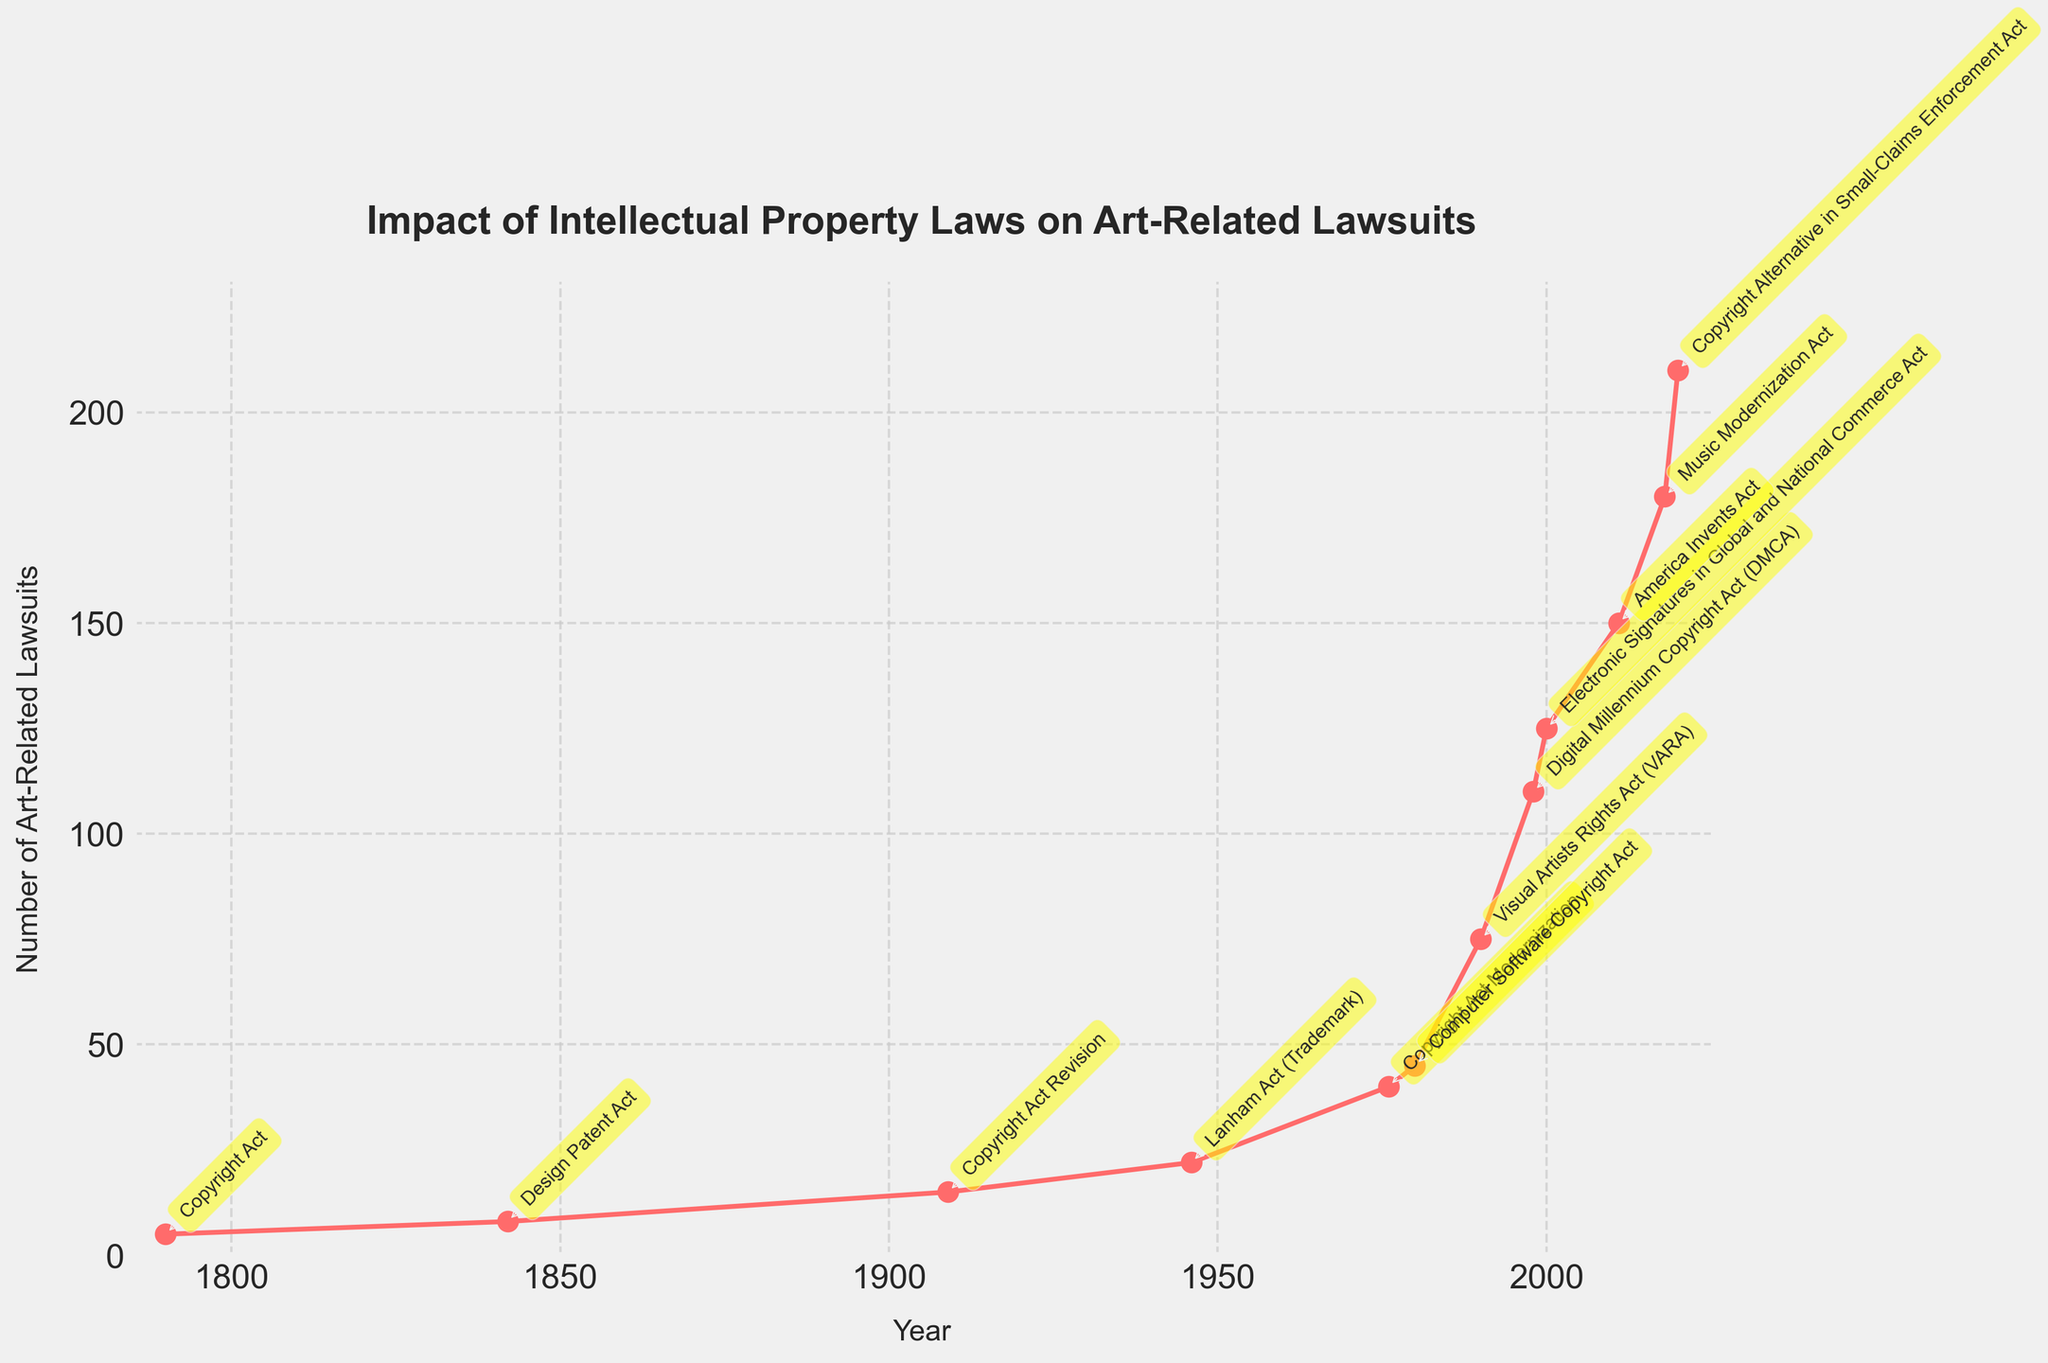what was the impact on art-related lawsuits after the Copyright Act of 1790? The figure shows the number of art-related lawsuits at various years. For 1790, associated with the Copyright Act, the number of lawsuits was indicated.
Answer: 5 How much did the number of art-related lawsuits increase between the Copyright Act of 1790 and the Design Patent Act of 1842? The number of lawsuits in 1790 was 5, and in 1842 it was 8. The increase can be calculated by subtracting the former from the latter: 8 - 5 = 3.
Answer: 3 Which law corresponds to the highest increase in the number of art-related lawsuits compared to its predecessor? By examining the rises in lawsuits at each legal milestone, the largest gap appears between the 1990 VARA (75) and the 1998 DMCA (110), giving an increase of 35, the highest among the intervals.
Answer: Digital Millennium Copyright Act Was there a higher impact on art-related lawsuits following the Lanham Act (1946) or the Copyright Act Modernization (1976)? The impact following the 1946 Lanham Act was 22, whereas the impact following the 1976 Copyright Act Modernization was 40. Hence, 1976 had a higher impact.
Answer: Copyright Act Modernization What is the overall trend in the number of art-related lawsuits from 1790 to 2020? Observing the line plot from 1790 to 2020, the lawsuits show a general upward trend, indicating that the number of art-related lawsuits has increased over time.
Answer: Upward Trend How many years after the Lanham Act was the Digital Millennium Copyright Act enacted? The Lanham Act was enacted in 1946 and the DMCA in 1998. Calculating the difference between these years: 1998 - 1946 = 52 years.
Answer: 52 years How does the number of art-related lawsuits following the Electronic Signatures in Global and National Commerce Act compare to those following the America Invents Act? The impact following the 2000 Electronic Signatures Act was 125, and the impact following the 2011 America Invents Act was 150. Therefore, there were 25 more lawsuits following the latter act.
Answer: America Invents Act has 25 more Which year saw the introduction of the law that corresponds to the highest increase in the number of art-related lawsuits? The largest increase among the legal milestones is observed between 2000 (Electronic Signatures Act - 125 lawsuits) and 2011 (America Invents Act - 150 lawsuits).
Answer: 2011 By how much did the impact on lawsuits change between the Computer Software Copyright Act and the Visual Artists Rights Act? The 1980 Computer Software Copyright Act had an impact of 45 lawsuits, while the Visual Artists Rights Act (VARA) in 1990 had an impact of 75 lawsuits. The change is 75 - 45 = 30.
Answer: 30 